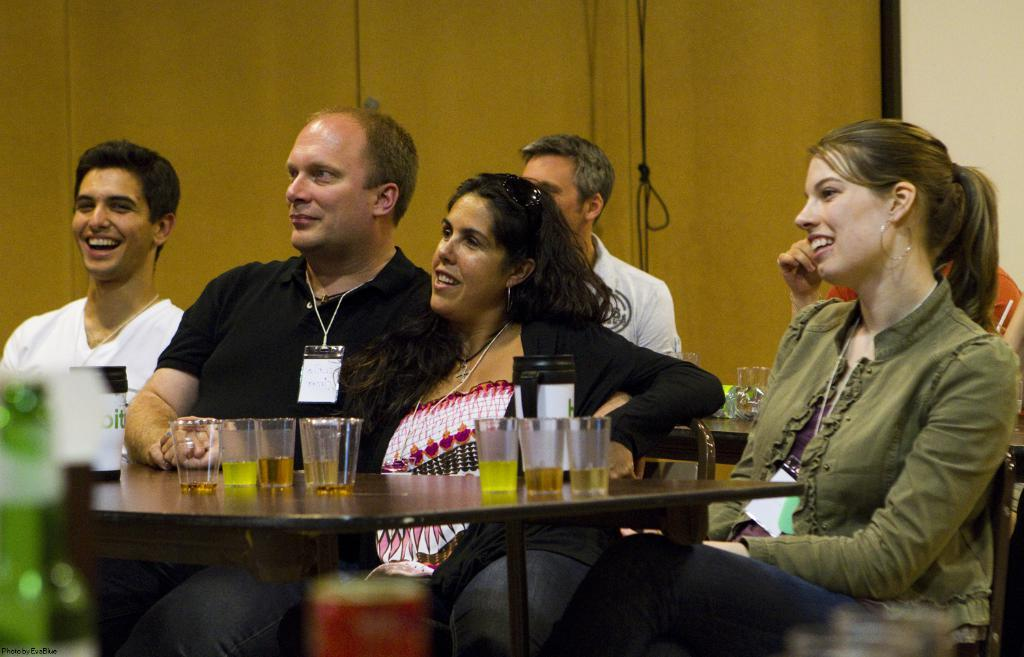What are the people in the image doing? The people in the image are sitting in front of a table. What objects can be seen on the table? Glasses are placed on the table. Where is the baby taking a bath in the image? There is no baby or bath present in the image. What type of market can be seen in the background of the image? There is no market visible in the image; it only shows people sitting in front of a table with glasses on it. 